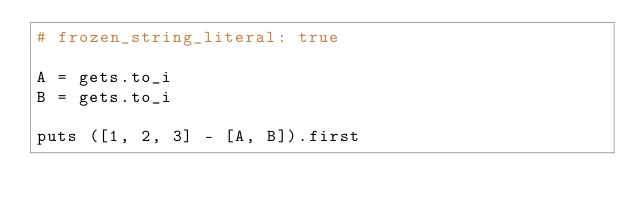<code> <loc_0><loc_0><loc_500><loc_500><_Ruby_># frozen_string_literal: true

A = gets.to_i
B = gets.to_i

puts ([1, 2, 3] - [A, B]).first
</code> 